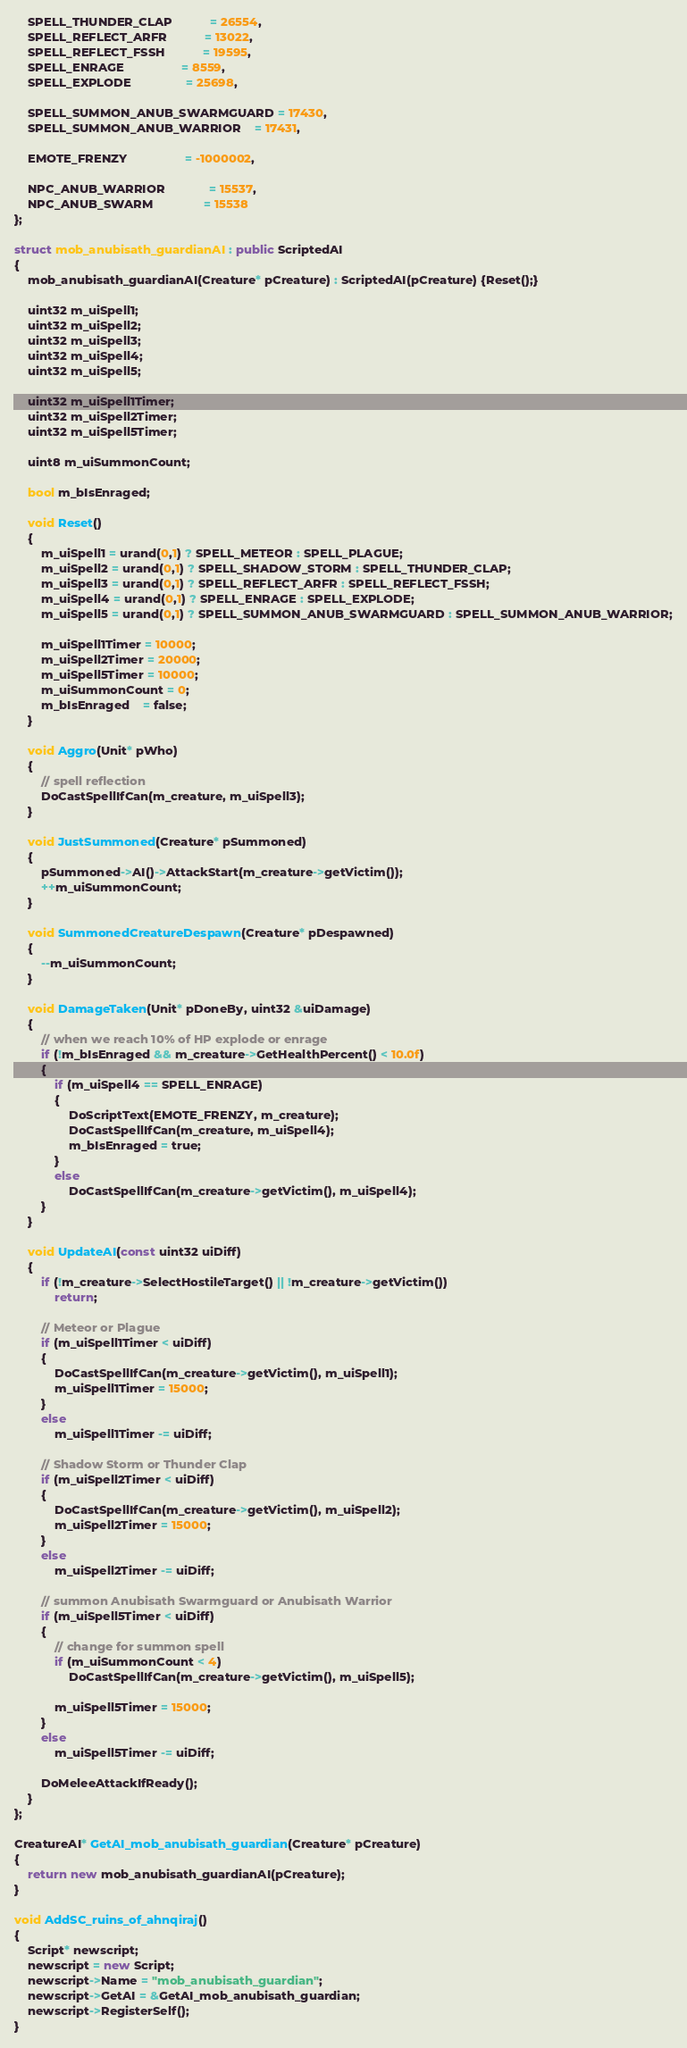<code> <loc_0><loc_0><loc_500><loc_500><_C++_>    SPELL_THUNDER_CLAP           = 26554,
    SPELL_REFLECT_ARFR           = 13022,
    SPELL_REFLECT_FSSH           = 19595,
    SPELL_ENRAGE                 = 8559,
    SPELL_EXPLODE                = 25698,

    SPELL_SUMMON_ANUB_SWARMGUARD = 17430,
    SPELL_SUMMON_ANUB_WARRIOR    = 17431,

    EMOTE_FRENZY                 = -1000002,

    NPC_ANUB_WARRIOR             = 15537,
    NPC_ANUB_SWARM               = 15538
};

struct mob_anubisath_guardianAI : public ScriptedAI
{
    mob_anubisath_guardianAI(Creature* pCreature) : ScriptedAI(pCreature) {Reset();}

    uint32 m_uiSpell1;
    uint32 m_uiSpell2;
    uint32 m_uiSpell3;
    uint32 m_uiSpell4;
    uint32 m_uiSpell5;

    uint32 m_uiSpell1Timer;
    uint32 m_uiSpell2Timer;
    uint32 m_uiSpell5Timer;

    uint8 m_uiSummonCount;

    bool m_bIsEnraged;

    void Reset()
    {
        m_uiSpell1 = urand(0,1) ? SPELL_METEOR : SPELL_PLAGUE;
        m_uiSpell2 = urand(0,1) ? SPELL_SHADOW_STORM : SPELL_THUNDER_CLAP;
        m_uiSpell3 = urand(0,1) ? SPELL_REFLECT_ARFR : SPELL_REFLECT_FSSH;
        m_uiSpell4 = urand(0,1) ? SPELL_ENRAGE : SPELL_EXPLODE;
        m_uiSpell5 = urand(0,1) ? SPELL_SUMMON_ANUB_SWARMGUARD : SPELL_SUMMON_ANUB_WARRIOR;

        m_uiSpell1Timer = 10000;
        m_uiSpell2Timer = 20000;
        m_uiSpell5Timer = 10000;
        m_uiSummonCount = 0;
        m_bIsEnraged    = false;
    }

    void Aggro(Unit* pWho)
    {
        // spell reflection
        DoCastSpellIfCan(m_creature, m_uiSpell3);
    }

    void JustSummoned(Creature* pSummoned)
    {
        pSummoned->AI()->AttackStart(m_creature->getVictim());
        ++m_uiSummonCount;
    }

    void SummonedCreatureDespawn(Creature* pDespawned)
    {
        --m_uiSummonCount;
    }

    void DamageTaken(Unit* pDoneBy, uint32 &uiDamage)
    {
        // when we reach 10% of HP explode or enrage
        if (!m_bIsEnraged && m_creature->GetHealthPercent() < 10.0f)
        {
            if (m_uiSpell4 == SPELL_ENRAGE)
            {
                DoScriptText(EMOTE_FRENZY, m_creature);
                DoCastSpellIfCan(m_creature, m_uiSpell4);
                m_bIsEnraged = true;
            }
            else
                DoCastSpellIfCan(m_creature->getVictim(), m_uiSpell4);
        }
    }

    void UpdateAI(const uint32 uiDiff)
    {
        if (!m_creature->SelectHostileTarget() || !m_creature->getVictim())
            return;

        // Meteor or Plague
        if (m_uiSpell1Timer < uiDiff)
        {
            DoCastSpellIfCan(m_creature->getVictim(), m_uiSpell1);
            m_uiSpell1Timer = 15000;
        }
        else
            m_uiSpell1Timer -= uiDiff;

        // Shadow Storm or Thunder Clap
        if (m_uiSpell2Timer < uiDiff)
        {
            DoCastSpellIfCan(m_creature->getVictim(), m_uiSpell2);
            m_uiSpell2Timer = 15000;
        }
        else
            m_uiSpell2Timer -= uiDiff;

        // summon Anubisath Swarmguard or Anubisath Warrior
        if (m_uiSpell5Timer < uiDiff)
        {
            // change for summon spell
            if (m_uiSummonCount < 4)
                DoCastSpellIfCan(m_creature->getVictim(), m_uiSpell5);

            m_uiSpell5Timer = 15000;
        }
        else
            m_uiSpell5Timer -= uiDiff;

        DoMeleeAttackIfReady();
    }
};

CreatureAI* GetAI_mob_anubisath_guardian(Creature* pCreature)
{
    return new mob_anubisath_guardianAI(pCreature);
}

void AddSC_ruins_of_ahnqiraj()
{
    Script* newscript;
    newscript = new Script;
    newscript->Name = "mob_anubisath_guardian";
    newscript->GetAI = &GetAI_mob_anubisath_guardian;
    newscript->RegisterSelf();
}
</code> 